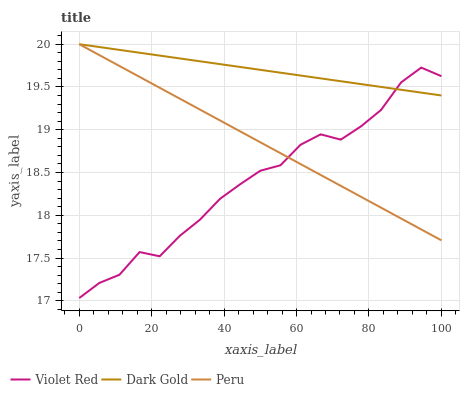Does Violet Red have the minimum area under the curve?
Answer yes or no. Yes. Does Dark Gold have the maximum area under the curve?
Answer yes or no. Yes. Does Peru have the minimum area under the curve?
Answer yes or no. No. Does Peru have the maximum area under the curve?
Answer yes or no. No. Is Peru the smoothest?
Answer yes or no. Yes. Is Violet Red the roughest?
Answer yes or no. Yes. Is Dark Gold the smoothest?
Answer yes or no. No. Is Dark Gold the roughest?
Answer yes or no. No. Does Violet Red have the lowest value?
Answer yes or no. Yes. Does Peru have the lowest value?
Answer yes or no. No. Does Dark Gold have the highest value?
Answer yes or no. Yes. Does Violet Red intersect Peru?
Answer yes or no. Yes. Is Violet Red less than Peru?
Answer yes or no. No. Is Violet Red greater than Peru?
Answer yes or no. No. 